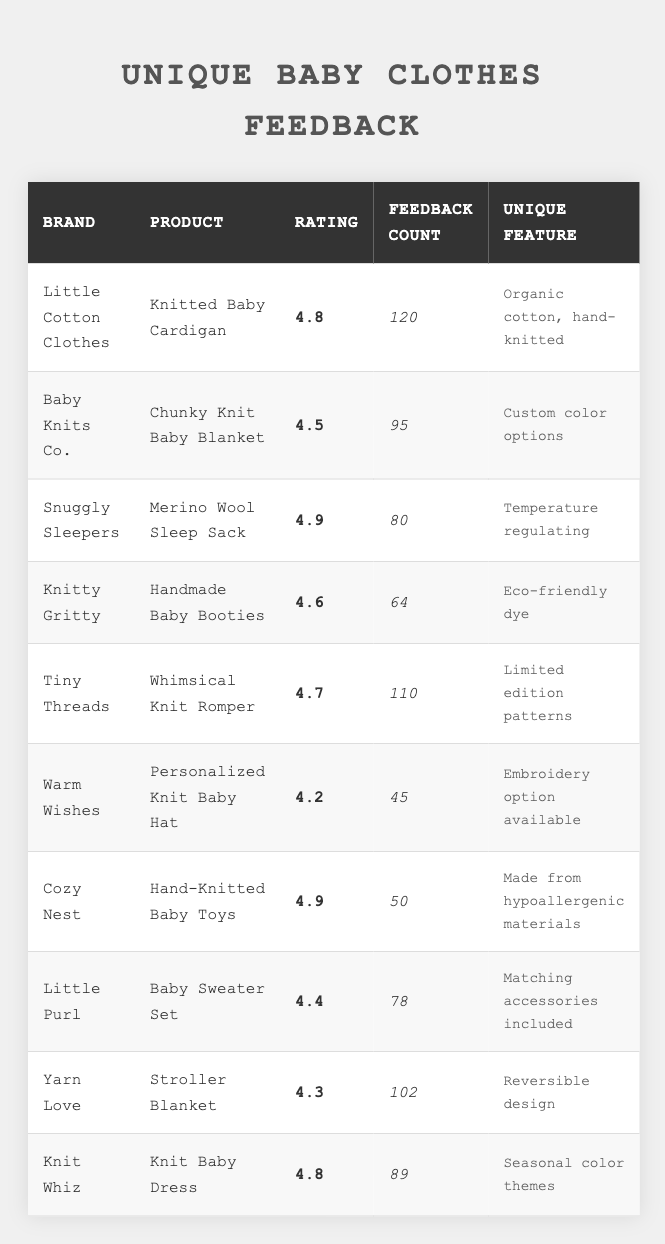What is the highest customer rating among the baby clothes listed? The highest rating can be found by scanning the 'Rating' column. The highest value is 4.9, which is associated with the 'Merino Wool Sleep Sack' and 'Hand-Knitted Baby Toys'.
Answer: 4.9 How many total feedback counts are there for the products listed? To find the total feedback counts, sum the values in the 'Feedback Count' column. The total is 120 + 95 + 80 + 64 + 110 + 45 + 50 + 78 + 102 + 89 =  1023.
Answer: 1023 Which product has the most feedback counts, and how many feedbacks did it receive? By checking the 'Feedback Count' column, the product with the most feedback is the 'Knitted Baby Cardigan' with 120 feedback counts.
Answer: Knitted Baby Cardigan, 120 Is there any product with a rating lower than 4.5? Reviewing the 'Rating' column shows that the 'Personalized Knit Baby Hat' has a rating of 4.2, which is below 4.5, confirming that there is a product with a lower rating.
Answer: Yes What percentage of the total feedback counts does the 'Merino Wool Sleep Sack' have? To calculate the percentage, first find the feedback count for the 'Merino Wool Sleep Sack' (80) and divide it by the total feedback counts (1023), then multiply by 100: (80 / 1023) * 100 = 7.82%.
Answer: 7.82% Which brand offers a product that is both personalized and has the lowest rating? The 'Warm Wishes' brand offers the 'Personalized Knit Baby Hat' with a rating of 4.2, which is indeed the lowest rating among the products listed.
Answer: Warm Wishes, 4.2 What is the difference in ratings between the 'Chunky Knit Baby Blanket' and the 'Knit Baby Dress'? The 'Chunky Knit Baby Blanket' has a rating of 4.5 and the 'Knit Baby Dress' has a rating of 4.8. The difference is calculated by subtracting: 4.8 - 4.5 = 0.3.
Answer: 0.3 How many products have a rating of 4.6 or higher? Counting the products with ratings of 4.6 or higher: 'Knitted Baby Cardigan' (4.8), 'Merino Wool Sleep Sack' (4.9), 'Tiny Threads' (4.7), 'Handmade Baby Booties' (4.6), 'Knit Baby Dress' (4.8), and 'Cozy Nest' (4.9). That totals to 6 products.
Answer: 6 Do any of the products feature seasonal color themes? The 'Knit Baby Dress' is noted for its seasonal color themes, confirming that there is such a feature among the products listed.
Answer: Yes What is the average rating of all the products listed? To calculate the average, sum all the ratings: (4.8 + 4.5 + 4.9 + 4.6 + 4.7 + 4.2 + 4.9 + 4.4 + 4.3 + 4.8) = 47.1. Then divide by the number of products (10): 47.1 / 10 = 4.71.
Answer: 4.71 Which unique feature appears most frequently among the products? Each product has a unique feature that seems to be distinct. After reviewing, all of them appear to offer entirely unique aspects, so no single feature appears more than once.
Answer: None 